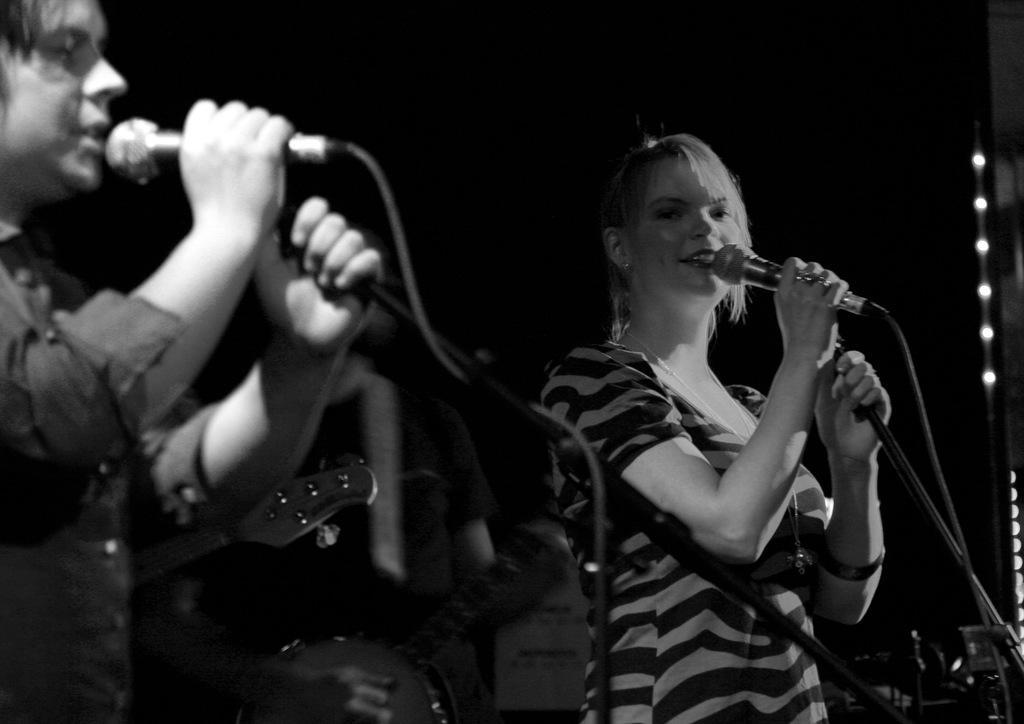Could you give a brief overview of what you see in this image? In this image there is a man and a woman holding mics in their hands are speaking something. 